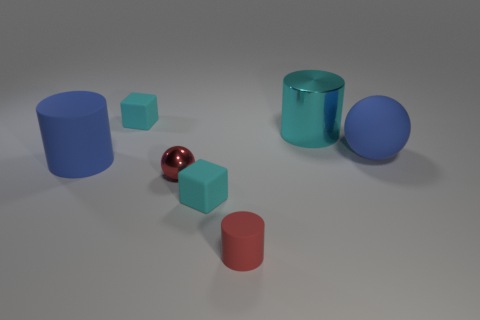Add 1 tiny gray metallic things. How many objects exist? 8 Subtract all cylinders. How many objects are left? 4 Subtract 0 yellow cylinders. How many objects are left? 7 Subtract all big blue rubber things. Subtract all cylinders. How many objects are left? 2 Add 3 large blue rubber balls. How many large blue rubber balls are left? 4 Add 6 large balls. How many large balls exist? 7 